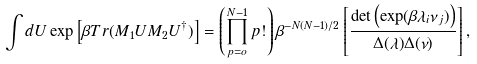Convert formula to latex. <formula><loc_0><loc_0><loc_500><loc_500>\int d U \exp \left [ \beta T r ( M _ { 1 } U M _ { 2 } U ^ { \dagger } ) \right ] = \left ( \prod _ { p = o } ^ { N - 1 } p ! \right ) \beta ^ { - N ( N - 1 ) / 2 } \left [ \frac { \det \left ( \exp ( \beta \lambda _ { i } \nu _ { j } ) \right ) } { \Delta ( \lambda ) \Delta ( \nu ) } \right ] ,</formula> 